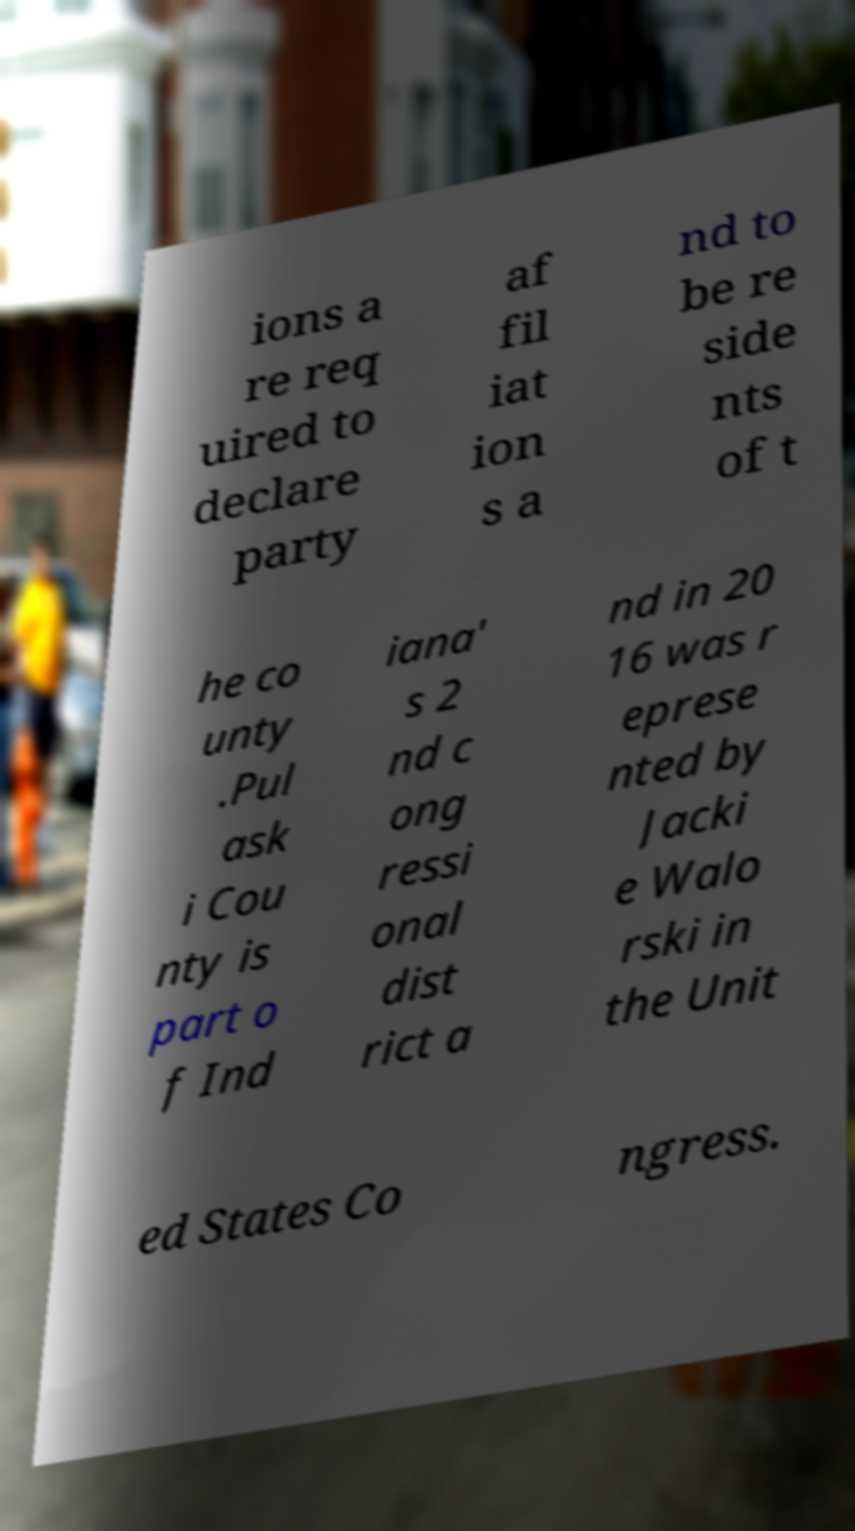I need the written content from this picture converted into text. Can you do that? ions a re req uired to declare party af fil iat ion s a nd to be re side nts of t he co unty .Pul ask i Cou nty is part o f Ind iana' s 2 nd c ong ressi onal dist rict a nd in 20 16 was r eprese nted by Jacki e Walo rski in the Unit ed States Co ngress. 